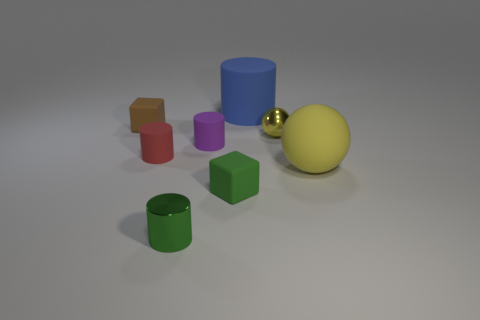Subtract all yellow cylinders. Subtract all green cubes. How many cylinders are left? 4 Add 1 cyan shiny cylinders. How many objects exist? 9 Subtract all cubes. How many objects are left? 6 Add 1 tiny purple things. How many tiny purple things are left? 2 Add 4 blue rubber cylinders. How many blue rubber cylinders exist? 5 Subtract 1 blue cylinders. How many objects are left? 7 Subtract all tiny green metallic things. Subtract all tiny green metal cylinders. How many objects are left? 6 